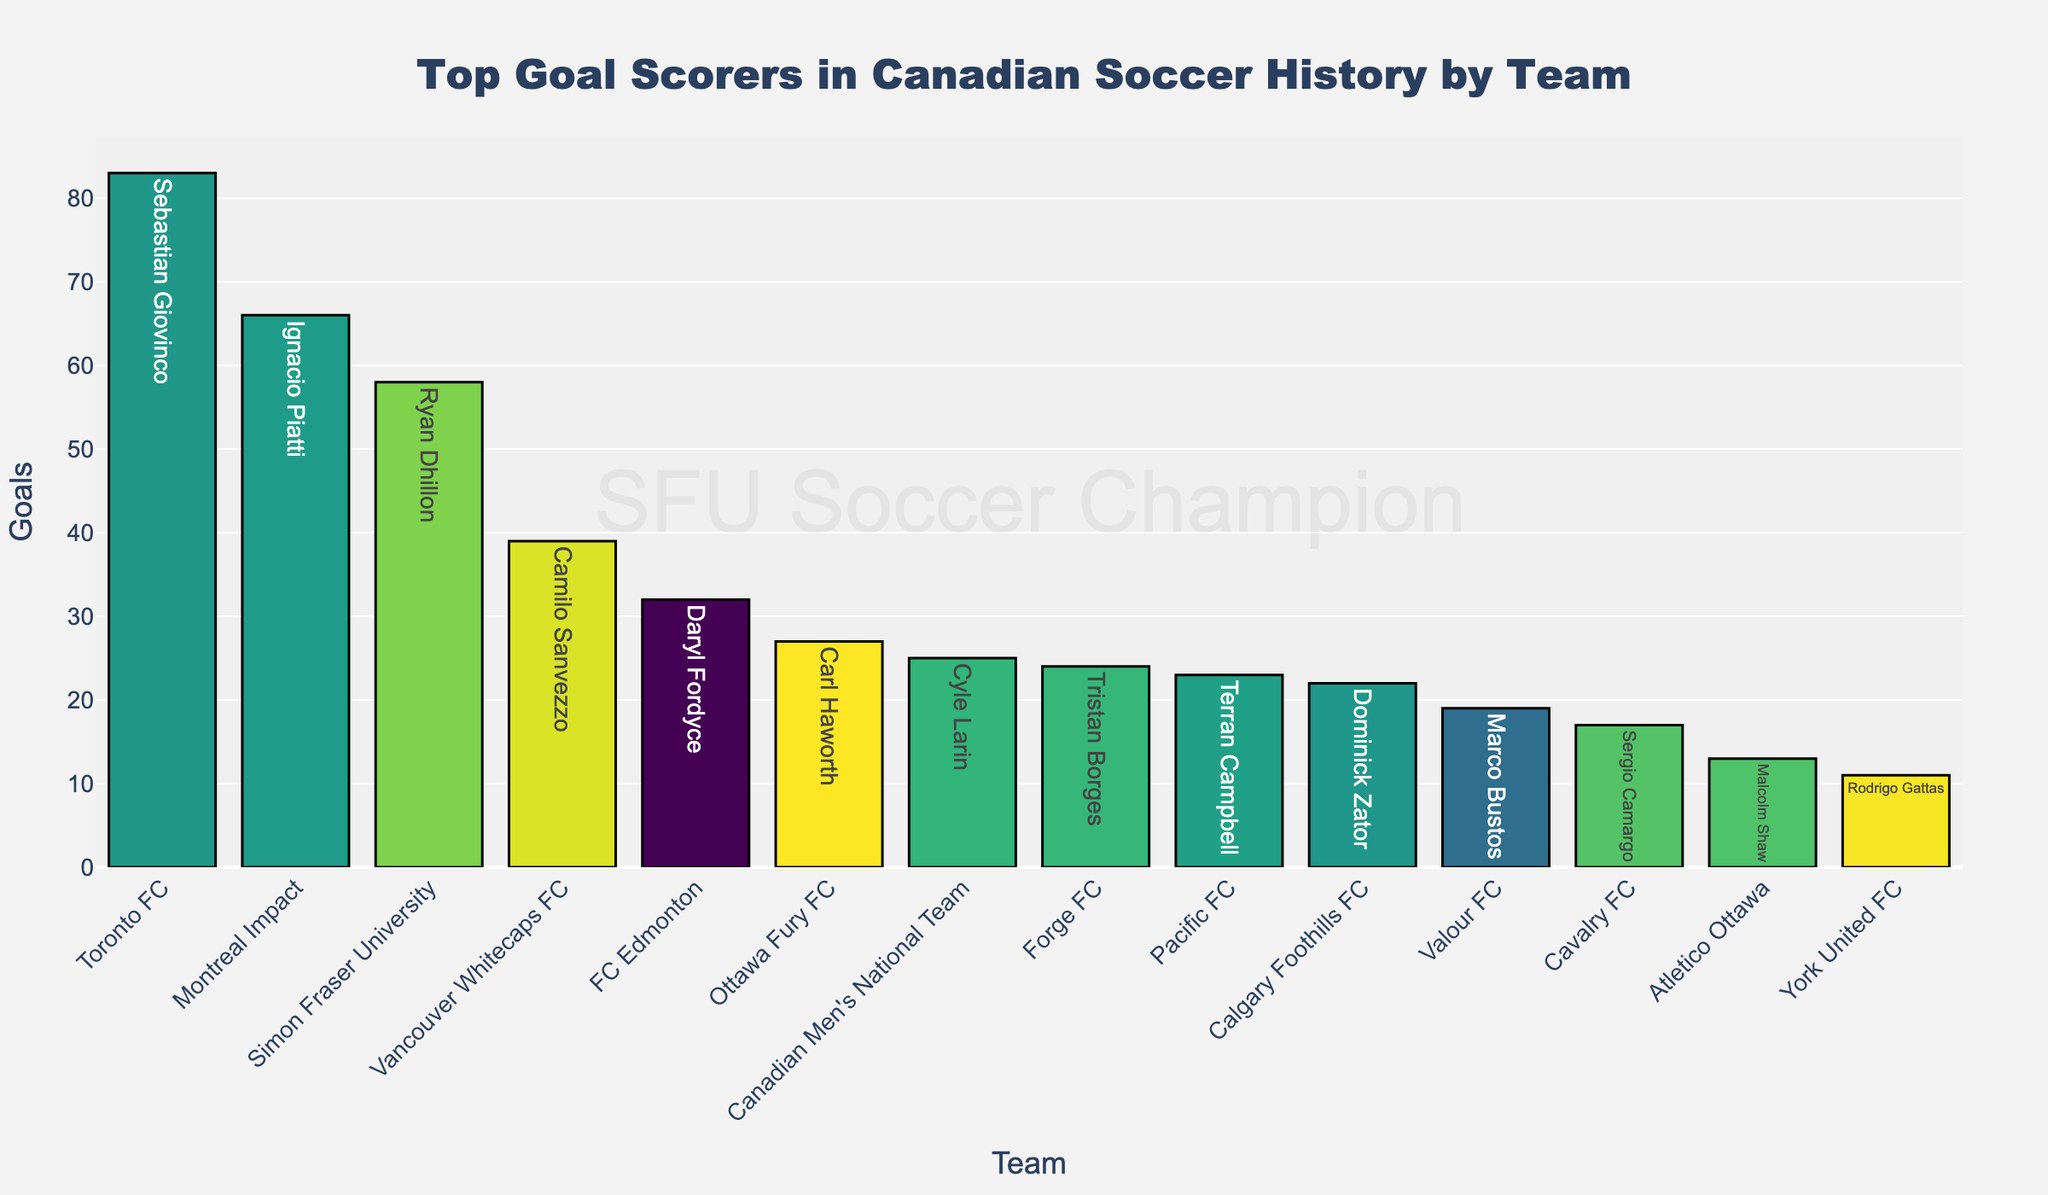Which team has the top goal scorer in Canadian soccer history? By observing the height of the bars, the tallest bar represents Toronto FC. The text on this tallest bar indicates the top goal scorer and the number of goals.
Answer: Toronto FC Who is the top goal scorer for Simon Fraser University, and how many goals did they score? Checking the bar labeled "Simon Fraser University," the text shows the top goal scorer's name and the number of goals scored.
Answer: Ryan Dhillon, 58 goals Which teams have top goal scorers with fewer than 20 goals? Looking at the bars with heights representing fewer than 20 goals, and noting the text of these bars, we can identify the teams.
Answer: York United FC and Cavalry FC Who scored more goals for their team, Carl Haworth for Ottawa Fury FC or Daryl Fordyce for FC Edmonton? Comparing the heights of the bars for Ottawa Fury FC and FC Edmonton, the bar for Ottawa Fury FC is slightly taller. The text on the bars indicates the actual numbers.
Answer: Carl Haworth How many goals did the top goal scorers of Toronto FC, Vancouver Whitecaps FC, and Montreal Impact score combined? Adding up the goals shown on each bar for these teams: 83 (Toronto FC) + 39 (Vancouver Whitecaps FC) + 66 (Montreal Impact).
Answer: 188 Which team's top goal scorer has the smallest number of goals, and what is that number? The shortest bar indicates the team with the lowest goal count for their top scorer. By checking the text on this bar, we can find the team and the number of goals.
Answer: York United FC, 11 goals Between Sebastian Giovinco and Cyle Larin, who scored more goals for their respective teams? Comparing the heights of the bars for Toronto FC and Canadian Men's National Team, the bar for Toronto FC is significantly taller. The text on these bars reveals the goal counts.
Answer: Sebastian Giovinco What is the average number of goals scored by the top scorers of all listed teams? Sum the goals for all top scorers and divide by the total number of teams: (83 + 39 + 66 + 25 + 58 + 22 + 32 + 27 + 19 + 24 + 17 + 23 + 11 + 13) / 14.
Answer: 33.86 How many more goals did Sebastian Giovinco score compared to Ignacio Piatti? Subtract Ignacio Piatti's goals from Sebastian Giovinco's goals: 83 (Sebastian Giovinco) - 66 (Ignacio Piatti).
Answer: 17 